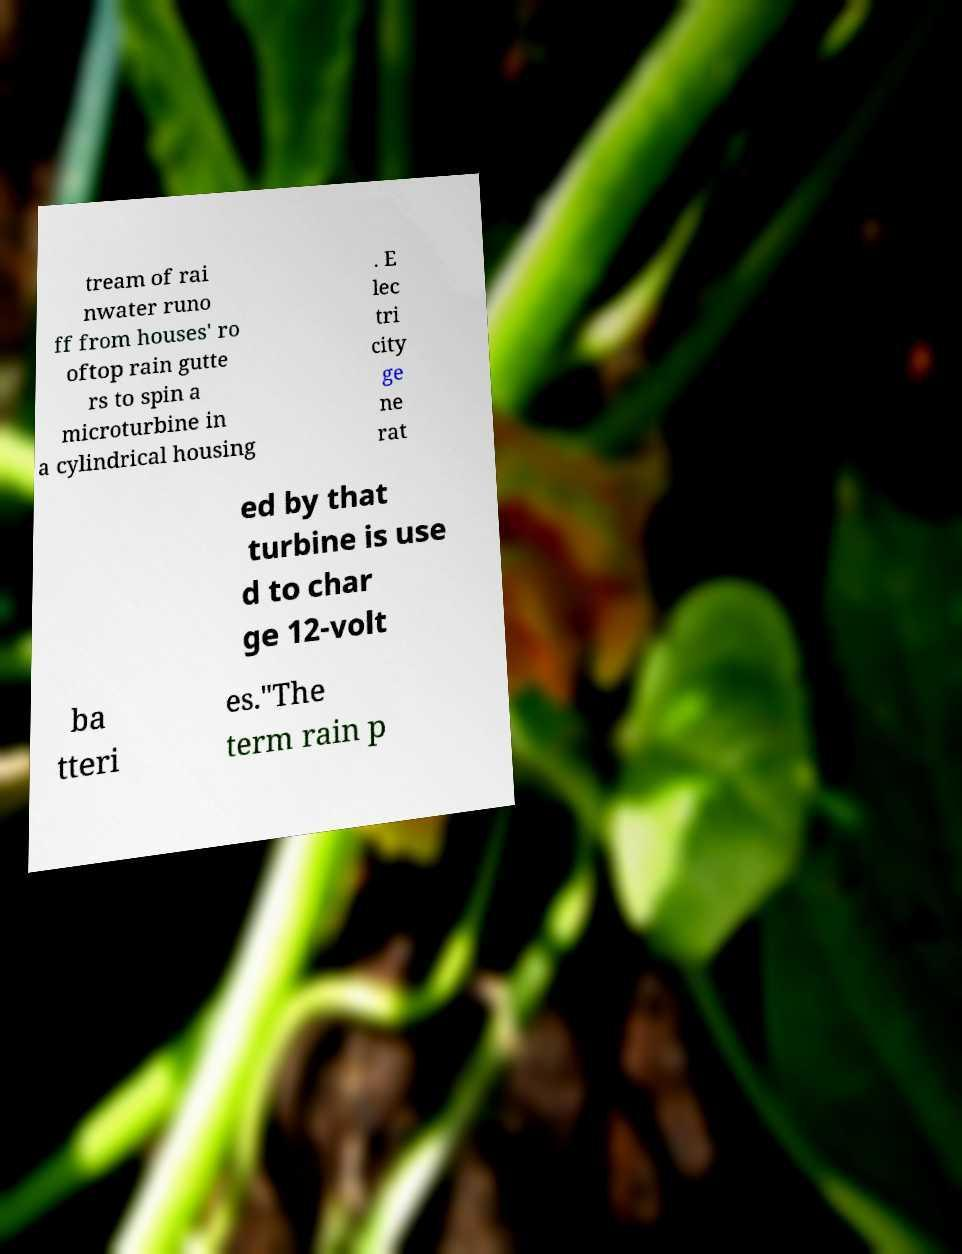Can you accurately transcribe the text from the provided image for me? tream of rai nwater runo ff from houses' ro oftop rain gutte rs to spin a microturbine in a cylindrical housing . E lec tri city ge ne rat ed by that turbine is use d to char ge 12-volt ba tteri es."The term rain p 